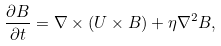Convert formula to latex. <formula><loc_0><loc_0><loc_500><loc_500>\frac { \partial B } { \partial t } = \nabla \times \left ( U \times B \right ) + \eta \nabla ^ { 2 } B ,</formula> 